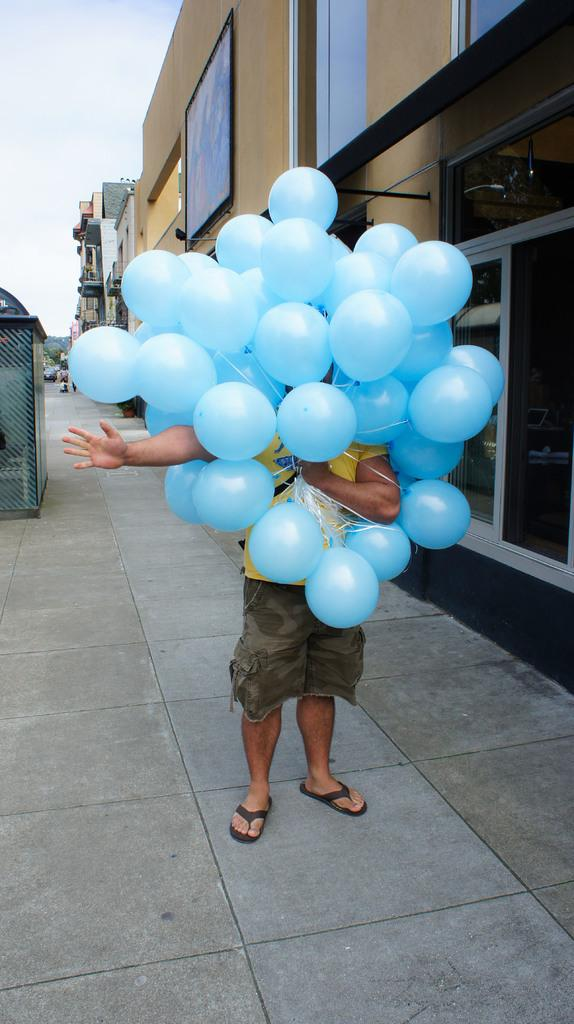What is the person in the image doing? The person is standing on the ground and holding a group of balloons. What can be seen in the background of the image? There are buildings with windows visible in the image. How would you describe the sky in the image? The sky is cloudy in the image. Can you see a plane flying over the seashore in the image? There is no plane or seashore present in the image. 